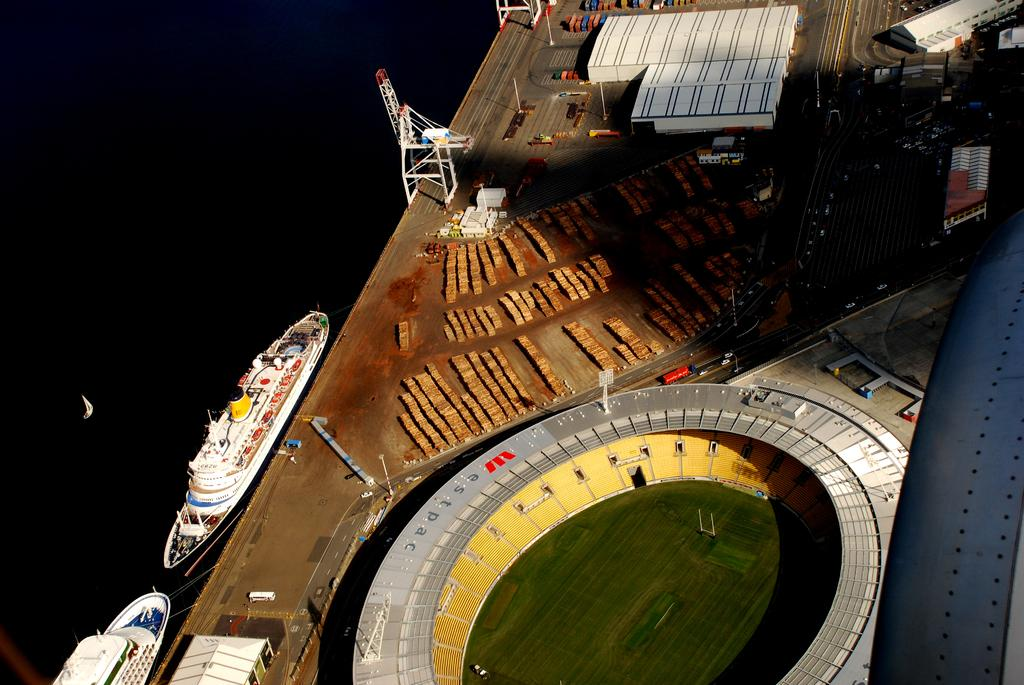What type of structure is visible in the image? There is a stadium in the image. What other structures can be seen in the image? There are sheds and poles visible in the image. What type of transportation is present in the image? There are vehicles in the image. What else can be seen in the image besides structures and vehicles? There are objects and ships in the image. How many steps are required to reach the top of the stadium in the image? There is no information about steps or the need to climb the stadium in the image. 